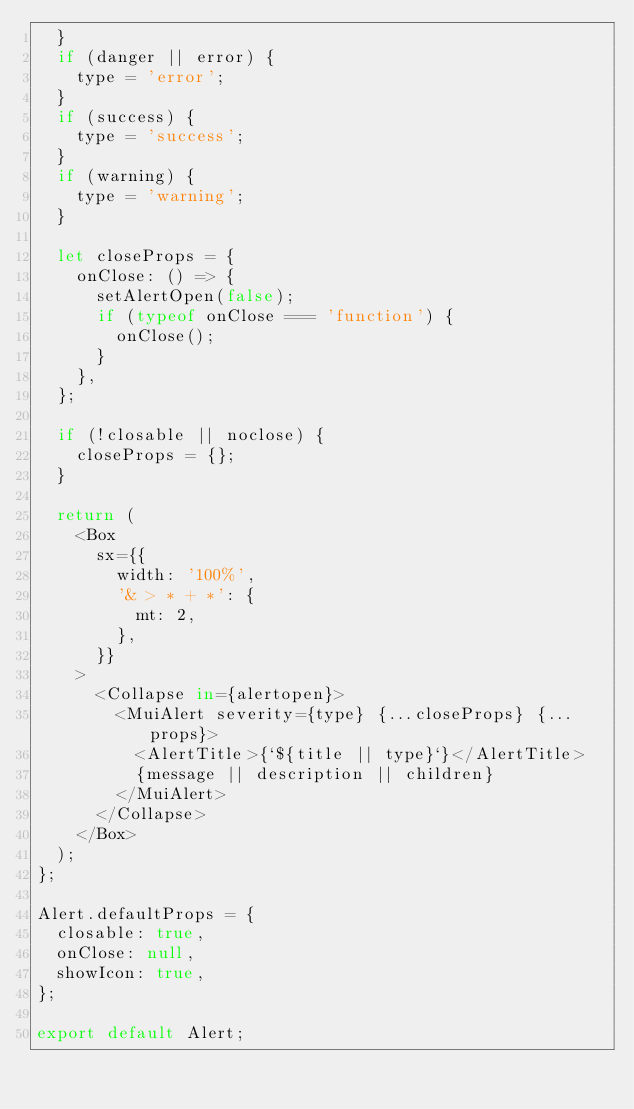Convert code to text. <code><loc_0><loc_0><loc_500><loc_500><_JavaScript_>  }
  if (danger || error) {
    type = 'error';
  }
  if (success) {
    type = 'success';
  }
  if (warning) {
    type = 'warning';
  }

  let closeProps = {
    onClose: () => {
      setAlertOpen(false);
      if (typeof onClose === 'function') {
        onClose();
      }
    },
  };

  if (!closable || noclose) {
    closeProps = {};
  }

  return (
    <Box
      sx={{
        width: '100%',
        '& > * + *': {
          mt: 2,
        },
      }}
    >
      <Collapse in={alertopen}>
        <MuiAlert severity={type} {...closeProps} {...props}>
          <AlertTitle>{`${title || type}`}</AlertTitle>
          {message || description || children}
        </MuiAlert>
      </Collapse>
    </Box>
  );
};

Alert.defaultProps = {
  closable: true,
  onClose: null,
  showIcon: true,
};

export default Alert;
</code> 